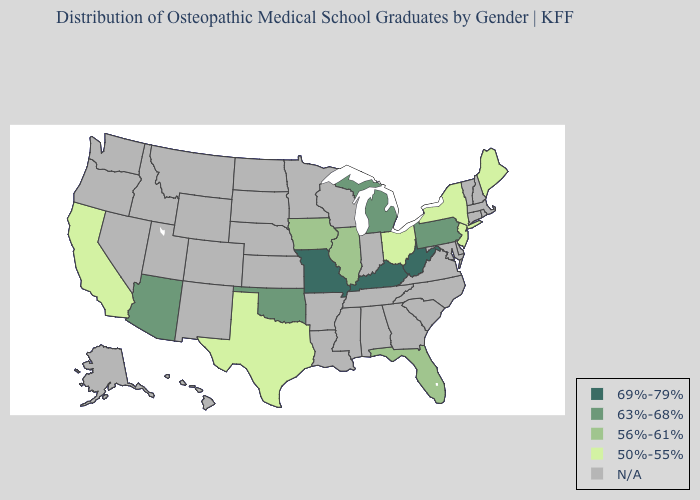What is the value of South Dakota?
Concise answer only. N/A. Does the map have missing data?
Keep it brief. Yes. What is the value of North Carolina?
Short answer required. N/A. Name the states that have a value in the range 63%-68%?
Give a very brief answer. Arizona, Michigan, Oklahoma, Pennsylvania. What is the value of Oklahoma?
Be succinct. 63%-68%. What is the highest value in the South ?
Short answer required. 69%-79%. Among the states that border New Hampshire , which have the lowest value?
Concise answer only. Maine. What is the highest value in states that border Colorado?
Be succinct. 63%-68%. Does the first symbol in the legend represent the smallest category?
Keep it brief. No. 